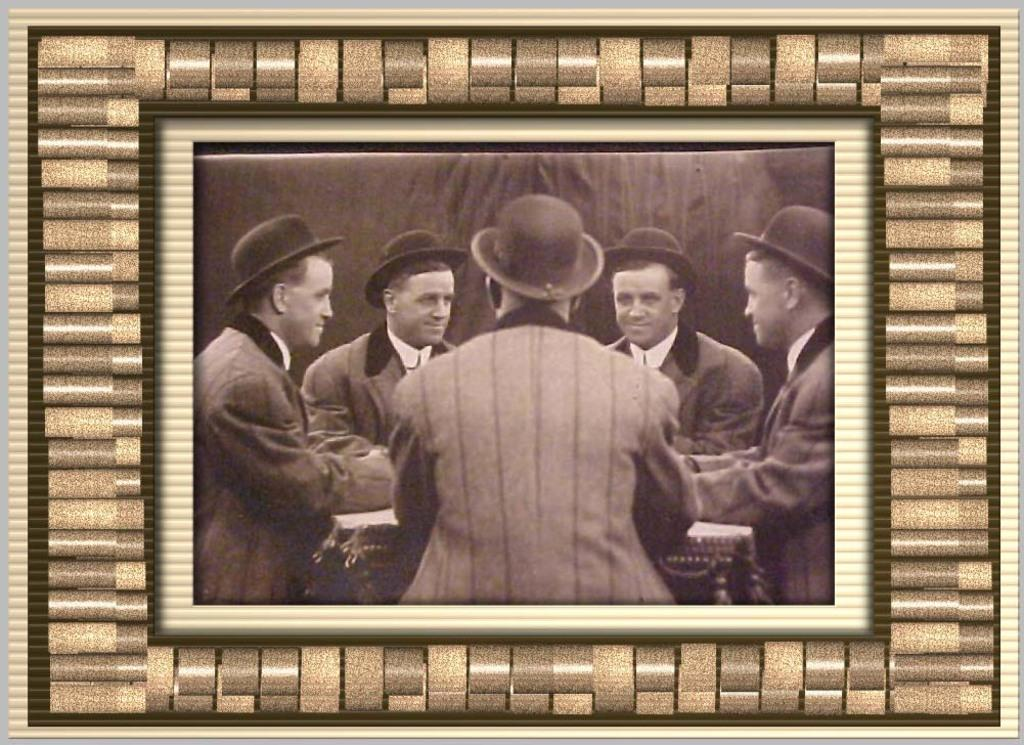What is the main subject of the image? There is a photo in the image. What can be seen in the photo? The photo contains five men. What are the men wearing in the photo? The men are wearing hats. What is the color scheme of the photo? The photo is black and white in color. Can you see the moon in the photo? There is no moon visible in the photo; it only contains five men wearing hats. What type of tin is being used by the men in the photo? There is no tin present in the photo; the men are wearing hats. 